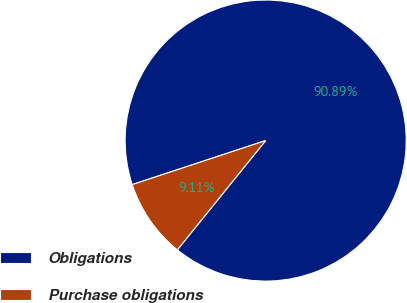<chart> <loc_0><loc_0><loc_500><loc_500><pie_chart><fcel>Obligations<fcel>Purchase obligations<nl><fcel>90.89%<fcel>9.11%<nl></chart> 